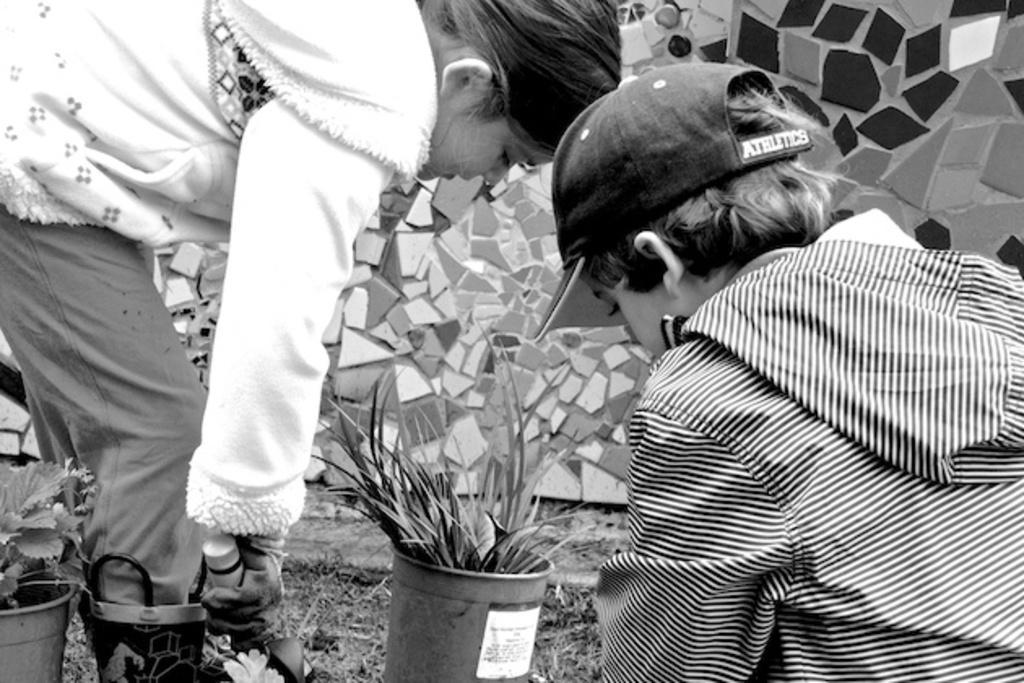Please provide a concise description of this image. In this image I can see two people and holding something. I can see few flower pots and a wall. The image is in black and white. 